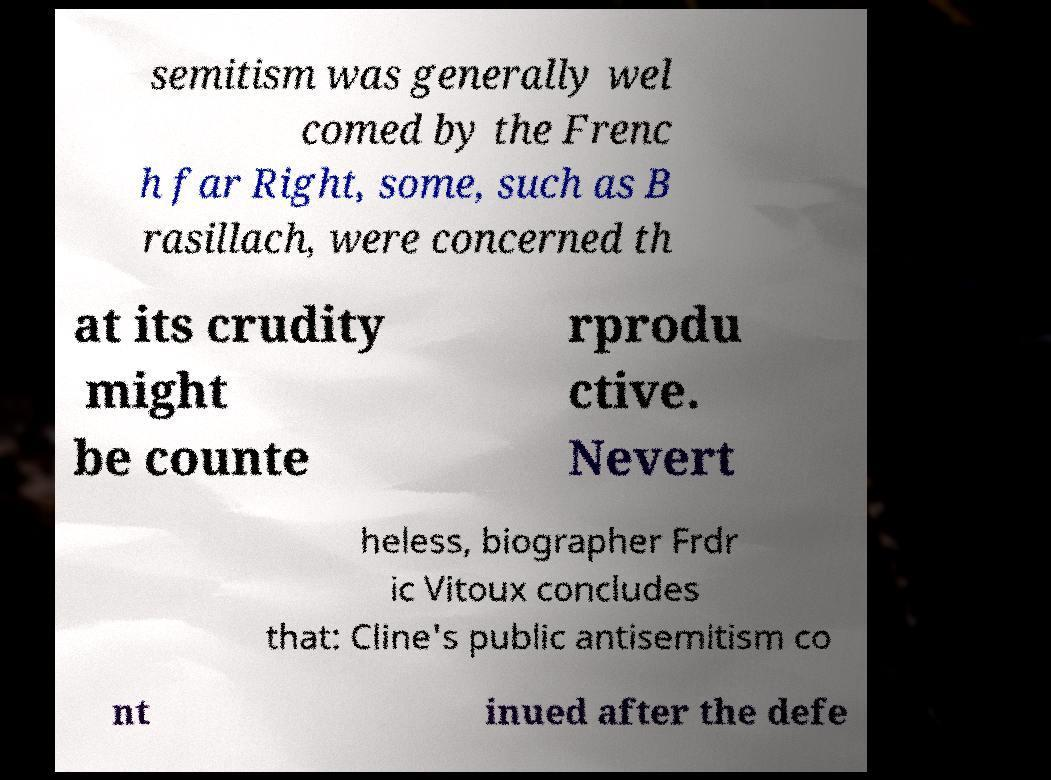Please read and relay the text visible in this image. What does it say? semitism was generally wel comed by the Frenc h far Right, some, such as B rasillach, were concerned th at its crudity might be counte rprodu ctive. Nevert heless, biographer Frdr ic Vitoux concludes that: Cline's public antisemitism co nt inued after the defe 